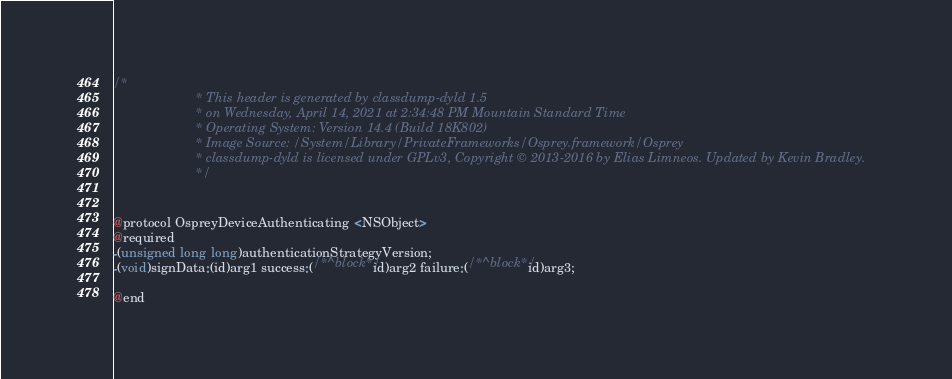Convert code to text. <code><loc_0><loc_0><loc_500><loc_500><_C_>/*
                       * This header is generated by classdump-dyld 1.5
                       * on Wednesday, April 14, 2021 at 2:34:48 PM Mountain Standard Time
                       * Operating System: Version 14.4 (Build 18K802)
                       * Image Source: /System/Library/PrivateFrameworks/Osprey.framework/Osprey
                       * classdump-dyld is licensed under GPLv3, Copyright © 2013-2016 by Elias Limneos. Updated by Kevin Bradley.
                       */


@protocol OspreyDeviceAuthenticating <NSObject>
@required
-(unsigned long long)authenticationStrategyVersion;
-(void)signData:(id)arg1 success:(/*^block*/id)arg2 failure:(/*^block*/id)arg3;

@end

</code> 